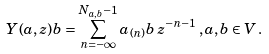Convert formula to latex. <formula><loc_0><loc_0><loc_500><loc_500>Y ( a , z ) b = \sum _ { n = - \infty } ^ { N _ { a , b } - 1 } a _ { ( n ) } b \, z ^ { - n - 1 } \, , a , b \in V \, .</formula> 